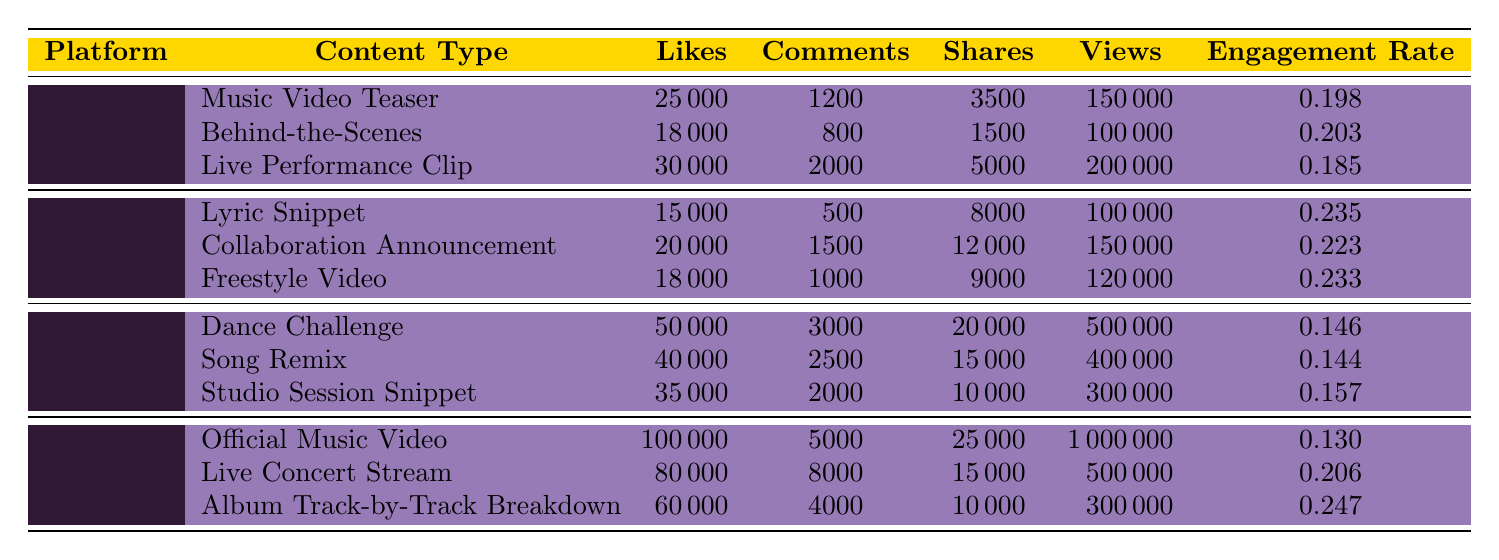which content type on Instagram received the highest number of likes? The row for Instagram content shows that the "Live Performance Clip" received 30000 likes, which is higher than the other content types listed, "Music Video Teaser" with 25000 likes and "Behind-the-Scenes" with 18000 likes.
Answer: Live Performance Clip what is the total number of shares for TikTok content? Adding up the shares for TikTok content types: Dance Challenge (20000) + Song Remix (15000) + Studio Session Snippet (10000) gives a total of 45000 shares.
Answer: 45000 did "Collaboration Announcement" on Twitter get more comments than "Live Concert Stream" on YouTube? "Collaboration Announcement" received 1500 comments while "Live Concert Stream" received 8000 comments. Since 1500 is less than 8000, the answer is no.
Answer: No which platform has the highest engagement rate for its content, and what is that rate? Evaluating the engagement rates, the content type with the highest rate is "Album Track-by-Track Breakdown" on YouTube at 0.247. This rate is higher than other engagement rates for all content types across all platforms.
Answer: YouTube, 0.247 what is the difference between the total likes of content on Instagram and YouTube? The total likes for Instagram are 25000 + 18000 + 30000 = 72800. For YouTube, the total likes are 100000 + 80000 + 60000 = 240000. The difference is 240000 - 72800 = 167200.
Answer: 167200 which content type on TikTok had the lowest engagement rate? Reviewing the engagement rates for TikTok content types, the "Dance Challenge" has an engagement rate of 0.146, which is the lowest among TikTok entries compared to 0.157 for "Studio Session Snippet" and 0.144 for "Song Remix."
Answer: Dance Challenge how many views did the "Official Music Video" receive on YouTube? The data for "Official Music Video" on YouTube shows it received 1000000 views, which is a direct extraction from the table.
Answer: 1000000 what content type on Twitter had the highest number of likes? Analyzing the likes for Twitter content, the "Collaboration Announcement" received the highest likes of 20000, more than "Lyric Snippet" (15000) and "Freestyle Video" (18000).
Answer: Collaboration Announcement 